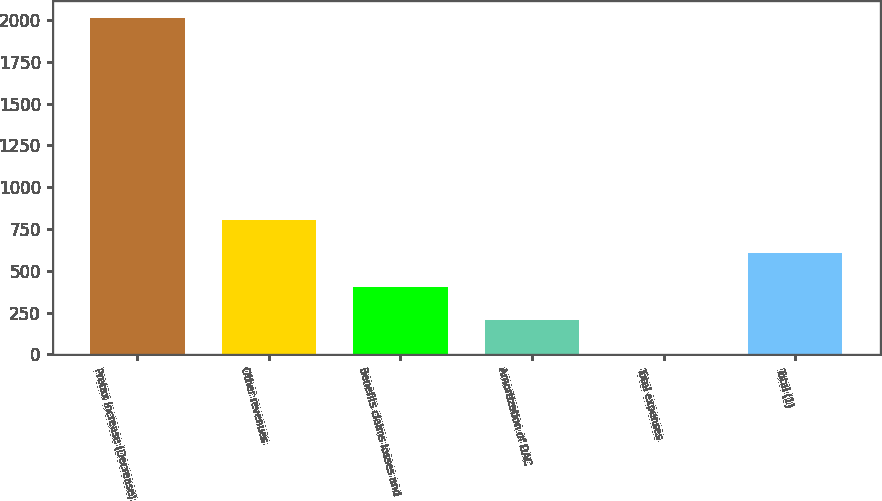Convert chart to OTSL. <chart><loc_0><loc_0><loc_500><loc_500><bar_chart><fcel>Pretax Increase (Decrease)<fcel>Other revenues<fcel>Benefits claims losses and<fcel>Amortization of DAC<fcel>Total expenses<fcel>Total (1)<nl><fcel>2012<fcel>806.6<fcel>404.8<fcel>203.9<fcel>3<fcel>605.7<nl></chart> 